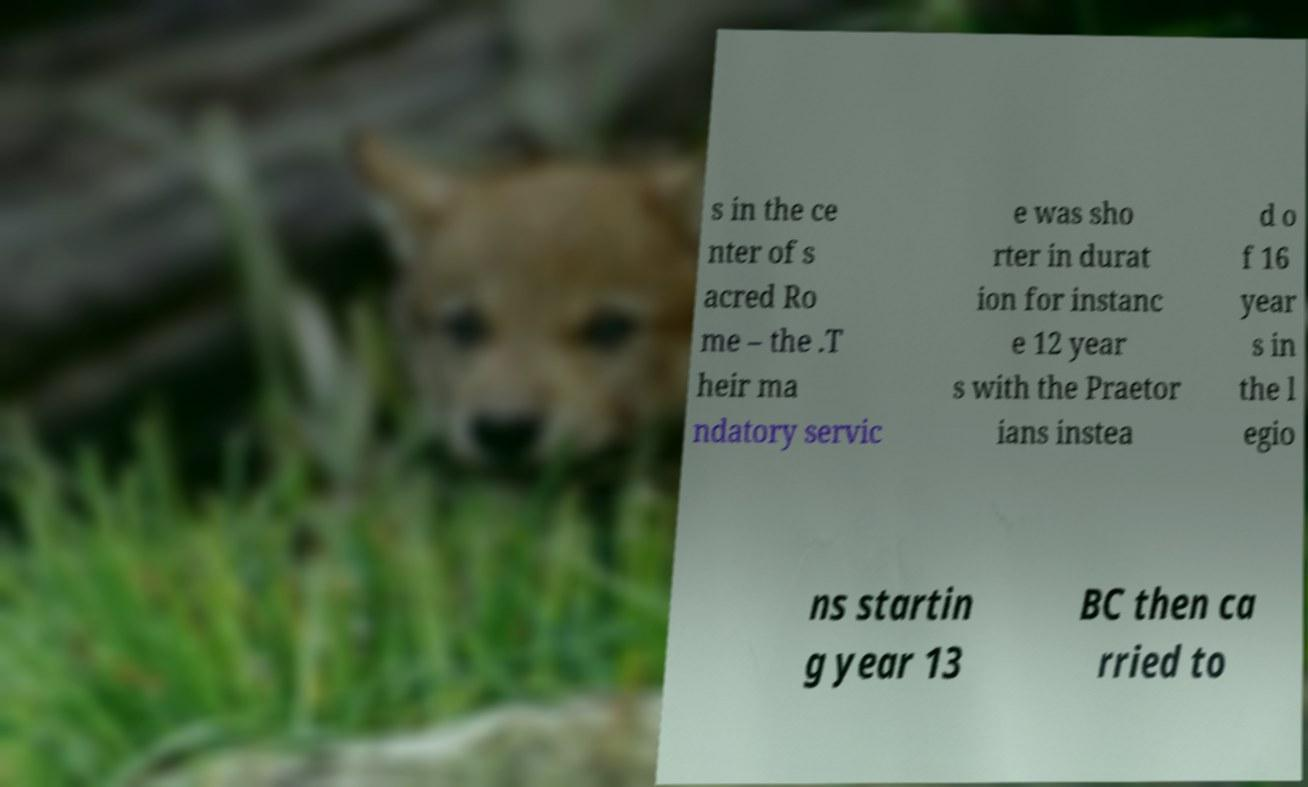Could you assist in decoding the text presented in this image and type it out clearly? s in the ce nter of s acred Ro me – the .T heir ma ndatory servic e was sho rter in durat ion for instanc e 12 year s with the Praetor ians instea d o f 16 year s in the l egio ns startin g year 13 BC then ca rried to 